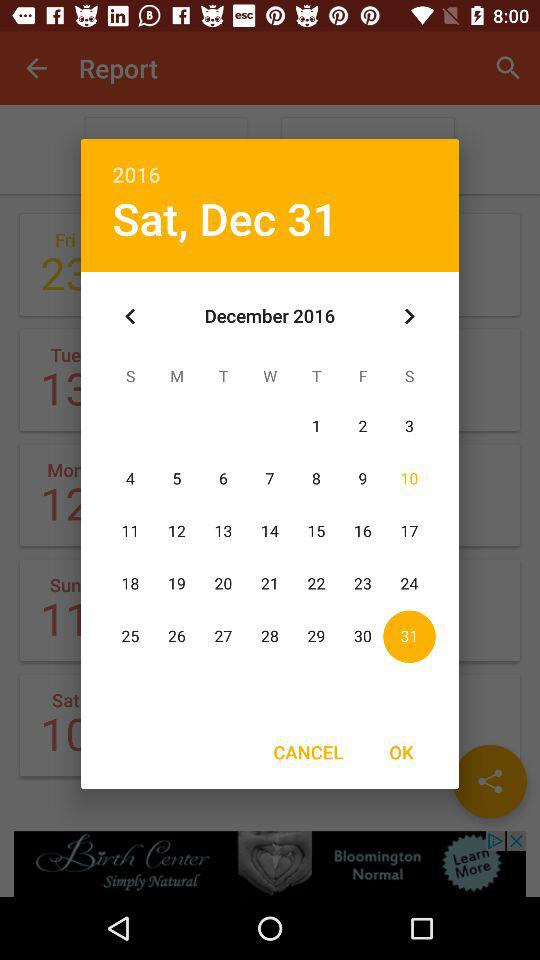Which date is selected? The selected date is Saturday, December 31, 2016. 